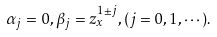Convert formula to latex. <formula><loc_0><loc_0><loc_500><loc_500>\alpha _ { j } = 0 , \beta _ { j } = z _ { x } ^ { 1 \pm j } , ( j = 0 , 1 , \cdots ) .</formula> 